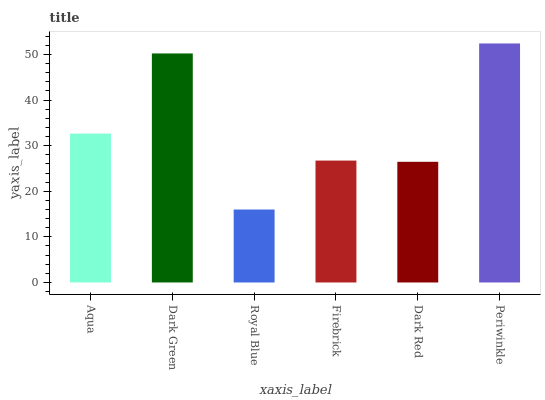Is Royal Blue the minimum?
Answer yes or no. Yes. Is Periwinkle the maximum?
Answer yes or no. Yes. Is Dark Green the minimum?
Answer yes or no. No. Is Dark Green the maximum?
Answer yes or no. No. Is Dark Green greater than Aqua?
Answer yes or no. Yes. Is Aqua less than Dark Green?
Answer yes or no. Yes. Is Aqua greater than Dark Green?
Answer yes or no. No. Is Dark Green less than Aqua?
Answer yes or no. No. Is Aqua the high median?
Answer yes or no. Yes. Is Firebrick the low median?
Answer yes or no. Yes. Is Dark Green the high median?
Answer yes or no. No. Is Dark Green the low median?
Answer yes or no. No. 